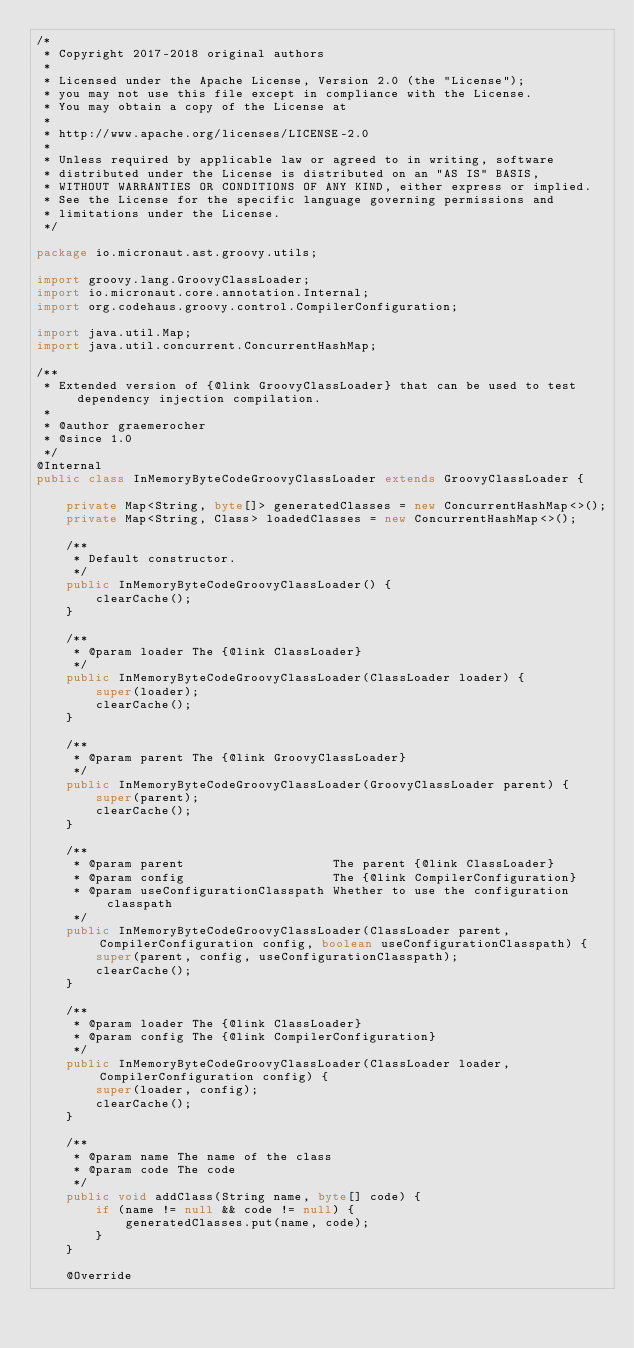<code> <loc_0><loc_0><loc_500><loc_500><_Java_>/*
 * Copyright 2017-2018 original authors
 *
 * Licensed under the Apache License, Version 2.0 (the "License");
 * you may not use this file except in compliance with the License.
 * You may obtain a copy of the License at
 *
 * http://www.apache.org/licenses/LICENSE-2.0
 *
 * Unless required by applicable law or agreed to in writing, software
 * distributed under the License is distributed on an "AS IS" BASIS,
 * WITHOUT WARRANTIES OR CONDITIONS OF ANY KIND, either express or implied.
 * See the License for the specific language governing permissions and
 * limitations under the License.
 */

package io.micronaut.ast.groovy.utils;

import groovy.lang.GroovyClassLoader;
import io.micronaut.core.annotation.Internal;
import org.codehaus.groovy.control.CompilerConfiguration;

import java.util.Map;
import java.util.concurrent.ConcurrentHashMap;

/**
 * Extended version of {@link GroovyClassLoader} that can be used to test dependency injection compilation.
 *
 * @author graemerocher
 * @since 1.0
 */
@Internal
public class InMemoryByteCodeGroovyClassLoader extends GroovyClassLoader {

    private Map<String, byte[]> generatedClasses = new ConcurrentHashMap<>();
    private Map<String, Class> loadedClasses = new ConcurrentHashMap<>();

    /**
     * Default constructor.
     */
    public InMemoryByteCodeGroovyClassLoader() {
        clearCache();
    }

    /**
     * @param loader The {@link ClassLoader}
     */
    public InMemoryByteCodeGroovyClassLoader(ClassLoader loader) {
        super(loader);
        clearCache();
    }

    /**
     * @param parent The {@link GroovyClassLoader}
     */
    public InMemoryByteCodeGroovyClassLoader(GroovyClassLoader parent) {
        super(parent);
        clearCache();
    }

    /**
     * @param parent                    The parent {@link ClassLoader}
     * @param config                    The {@link CompilerConfiguration}
     * @param useConfigurationClasspath Whether to use the configuration classpath
     */
    public InMemoryByteCodeGroovyClassLoader(ClassLoader parent, CompilerConfiguration config, boolean useConfigurationClasspath) {
        super(parent, config, useConfigurationClasspath);
        clearCache();
    }

    /**
     * @param loader The {@link ClassLoader}
     * @param config The {@link CompilerConfiguration}
     */
    public InMemoryByteCodeGroovyClassLoader(ClassLoader loader, CompilerConfiguration config) {
        super(loader, config);
        clearCache();
    }

    /**
     * @param name The name of the class
     * @param code The code
     */
    public void addClass(String name, byte[] code) {
        if (name != null && code != null) {
            generatedClasses.put(name, code);
        }
    }

    @Override</code> 